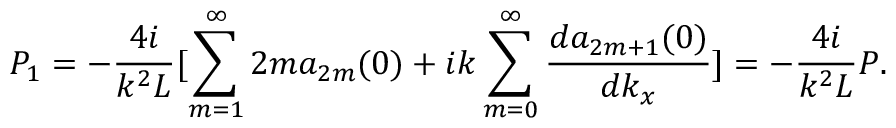<formula> <loc_0><loc_0><loc_500><loc_500>P _ { 1 } = - \frac { 4 i } { k ^ { 2 } L } [ \sum _ { m = 1 } ^ { \infty } 2 m a _ { 2 m } ( 0 ) + i k \sum _ { m = 0 } ^ { \infty } \frac { d a _ { 2 m + 1 } ( 0 ) } { d k _ { x } } ] = - \frac { 4 i } { k ^ { 2 } L } P .</formula> 